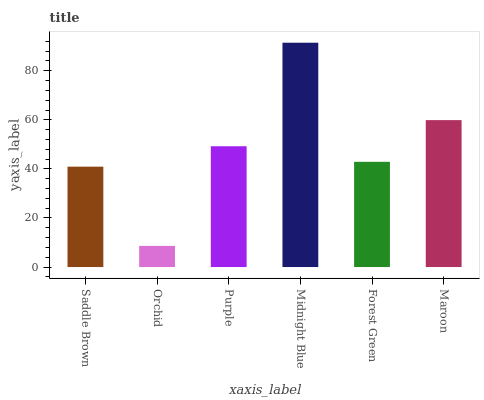Is Purple the minimum?
Answer yes or no. No. Is Purple the maximum?
Answer yes or no. No. Is Purple greater than Orchid?
Answer yes or no. Yes. Is Orchid less than Purple?
Answer yes or no. Yes. Is Orchid greater than Purple?
Answer yes or no. No. Is Purple less than Orchid?
Answer yes or no. No. Is Purple the high median?
Answer yes or no. Yes. Is Forest Green the low median?
Answer yes or no. Yes. Is Maroon the high median?
Answer yes or no. No. Is Midnight Blue the low median?
Answer yes or no. No. 